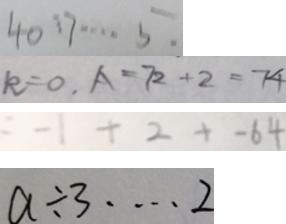Convert formula to latex. <formula><loc_0><loc_0><loc_500><loc_500>4 0 : 7 \cdots 5 . 
 k = 0 , A = 7 2 + 2 = 7 4 
 = - 1 + 2 + - 6 4 
 a \div 3 \cdots 2</formula> 